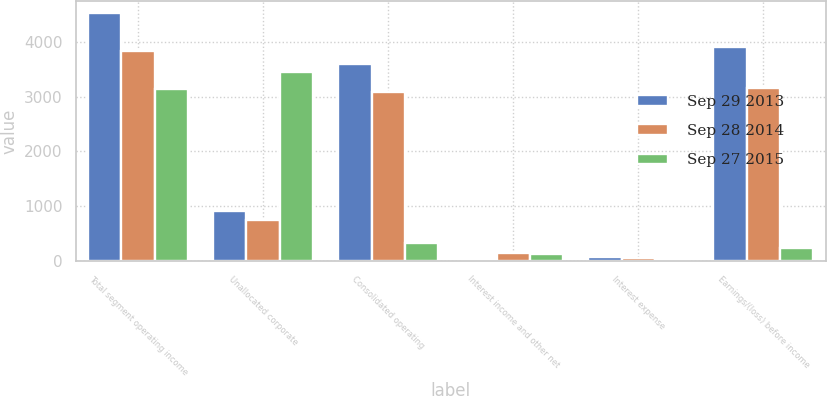<chart> <loc_0><loc_0><loc_500><loc_500><stacked_bar_chart><ecel><fcel>Total segment operating income<fcel>Unallocated corporate<fcel>Consolidated operating<fcel>Interest income and other net<fcel>Interest expense<fcel>Earnings/(loss) before income<nl><fcel>Sep 29 2013<fcel>4521.1<fcel>920.1<fcel>3601<fcel>43<fcel>70.5<fcel>3903<nl><fcel>Sep 28 2014<fcel>3831.1<fcel>750<fcel>3081.1<fcel>142.7<fcel>64.1<fcel>3159.7<nl><fcel>Sep 27 2015<fcel>3131.6<fcel>3457<fcel>325.4<fcel>123.6<fcel>28.1<fcel>229.9<nl></chart> 